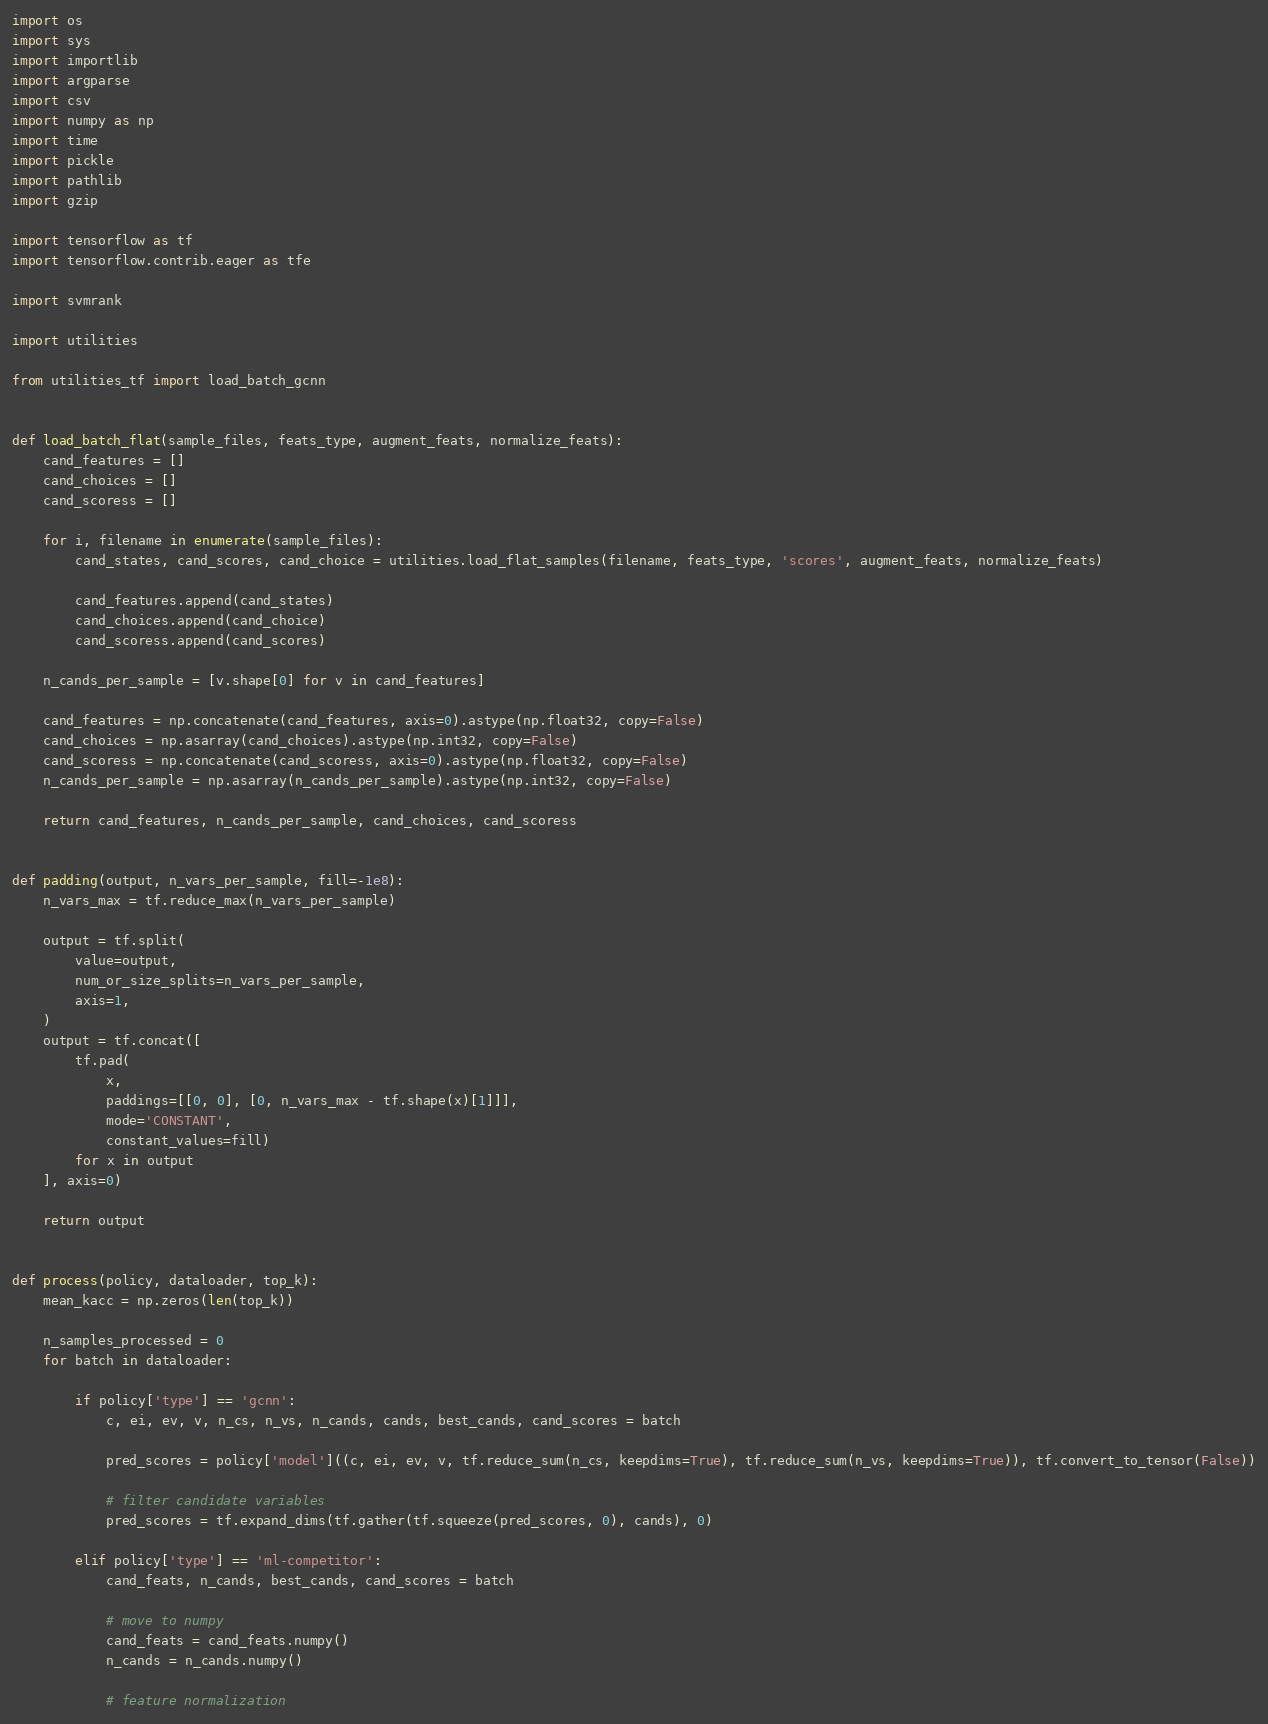<code> <loc_0><loc_0><loc_500><loc_500><_Python_>import os
import sys
import importlib
import argparse
import csv
import numpy as np
import time
import pickle
import pathlib
import gzip

import tensorflow as tf
import tensorflow.contrib.eager as tfe

import svmrank

import utilities

from utilities_tf import load_batch_gcnn


def load_batch_flat(sample_files, feats_type, augment_feats, normalize_feats):
    cand_features = []
    cand_choices = []
    cand_scoress = []

    for i, filename in enumerate(sample_files):
        cand_states, cand_scores, cand_choice = utilities.load_flat_samples(filename, feats_type, 'scores', augment_feats, normalize_feats)

        cand_features.append(cand_states)
        cand_choices.append(cand_choice)
        cand_scoress.append(cand_scores)

    n_cands_per_sample = [v.shape[0] for v in cand_features]

    cand_features = np.concatenate(cand_features, axis=0).astype(np.float32, copy=False)
    cand_choices = np.asarray(cand_choices).astype(np.int32, copy=False)
    cand_scoress = np.concatenate(cand_scoress, axis=0).astype(np.float32, copy=False)
    n_cands_per_sample = np.asarray(n_cands_per_sample).astype(np.int32, copy=False)

    return cand_features, n_cands_per_sample, cand_choices, cand_scoress


def padding(output, n_vars_per_sample, fill=-1e8):
    n_vars_max = tf.reduce_max(n_vars_per_sample)

    output = tf.split(
        value=output,
        num_or_size_splits=n_vars_per_sample,
        axis=1,
    )
    output = tf.concat([
        tf.pad(
            x,
            paddings=[[0, 0], [0, n_vars_max - tf.shape(x)[1]]],
            mode='CONSTANT',
            constant_values=fill)
        for x in output
    ], axis=0)

    return output


def process(policy, dataloader, top_k):
    mean_kacc = np.zeros(len(top_k))

    n_samples_processed = 0
    for batch in dataloader:

        if policy['type'] == 'gcnn':
            c, ei, ev, v, n_cs, n_vs, n_cands, cands, best_cands, cand_scores = batch

            pred_scores = policy['model']((c, ei, ev, v, tf.reduce_sum(n_cs, keepdims=True), tf.reduce_sum(n_vs, keepdims=True)), tf.convert_to_tensor(False))

            # filter candidate variables
            pred_scores = tf.expand_dims(tf.gather(tf.squeeze(pred_scores, 0), cands), 0)

        elif policy['type'] == 'ml-competitor':
            cand_feats, n_cands, best_cands, cand_scores = batch

            # move to numpy
            cand_feats = cand_feats.numpy()
            n_cands = n_cands.numpy()

            # feature normalization</code> 